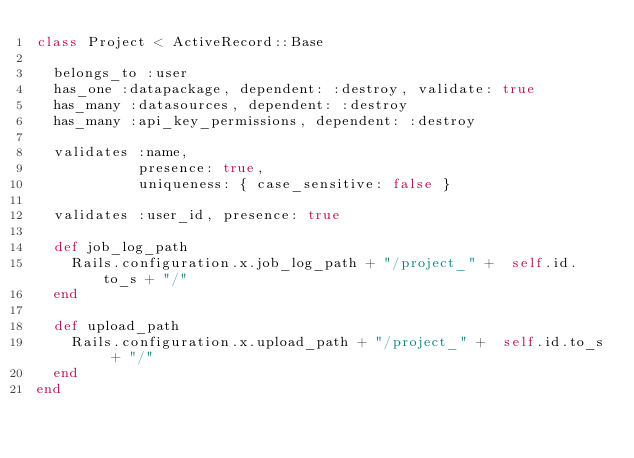Convert code to text. <code><loc_0><loc_0><loc_500><loc_500><_Ruby_>class Project < ActiveRecord::Base

  belongs_to :user
  has_one :datapackage, dependent: :destroy, validate: true
  has_many :datasources, dependent: :destroy
  has_many :api_key_permissions, dependent: :destroy

  validates :name,
            presence: true,
            uniqueness: { case_sensitive: false }

  validates :user_id, presence: true

  def job_log_path
    Rails.configuration.x.job_log_path + "/project_" +  self.id.to_s + "/"
  end

  def upload_path
    Rails.configuration.x.upload_path + "/project_" +  self.id.to_s + "/"
  end
end
</code> 